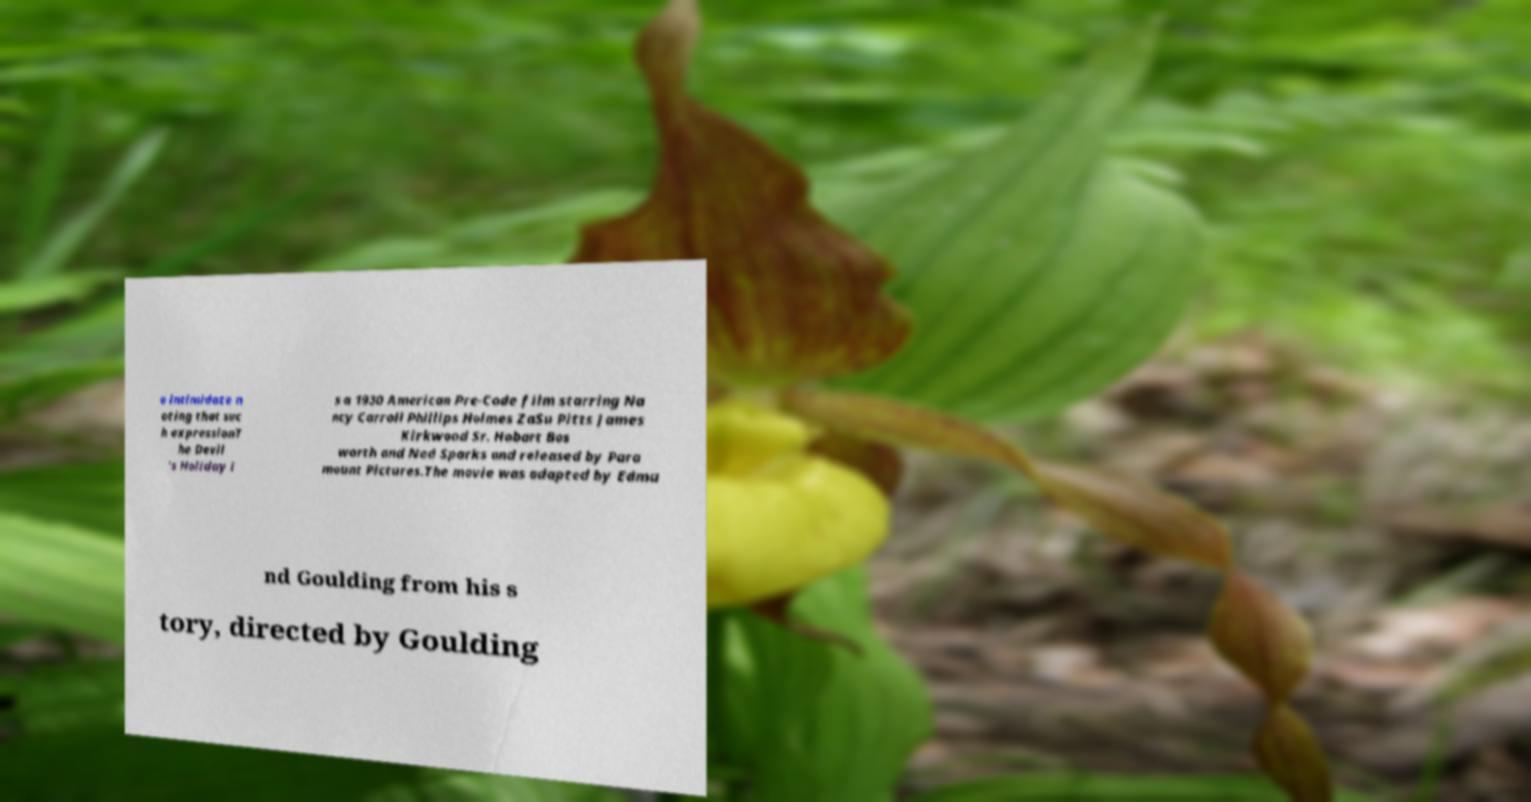Please identify and transcribe the text found in this image. o intimidate n oting that suc h expressionT he Devil 's Holiday i s a 1930 American Pre-Code film starring Na ncy Carroll Phillips Holmes ZaSu Pitts James Kirkwood Sr. Hobart Bos worth and Ned Sparks and released by Para mount Pictures.The movie was adapted by Edmu nd Goulding from his s tory, directed by Goulding 